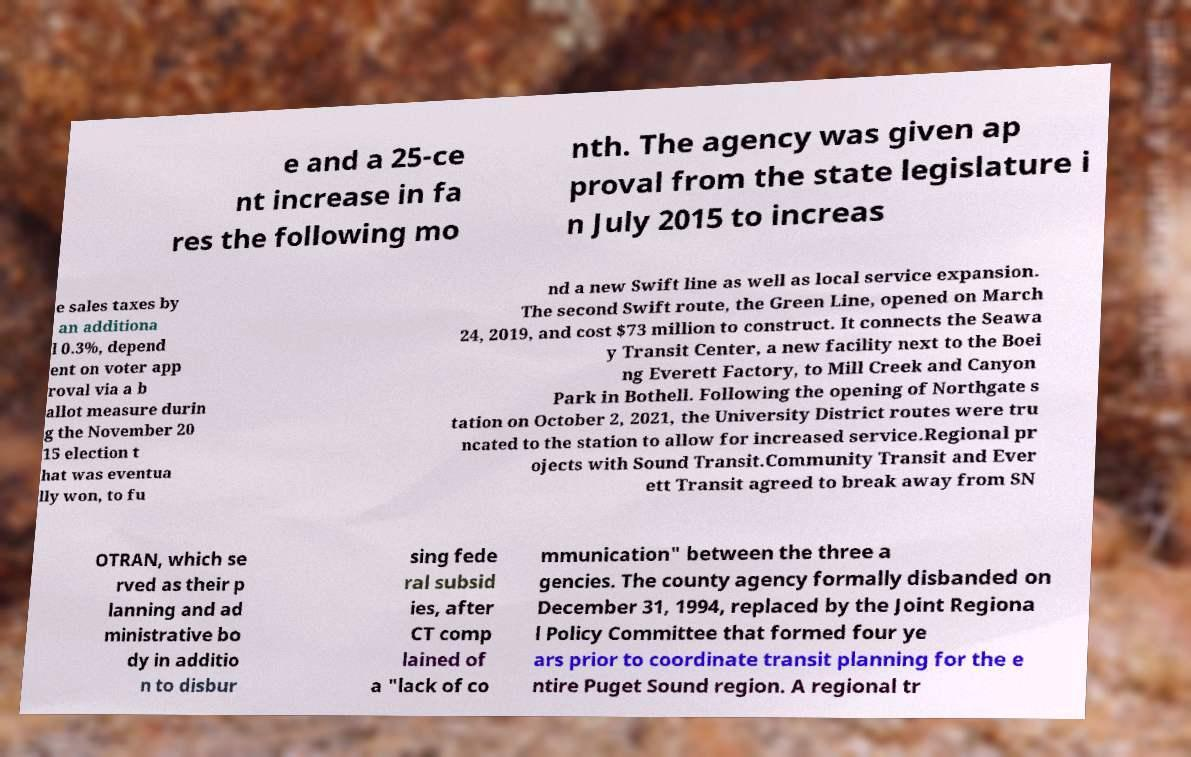Please read and relay the text visible in this image. What does it say? e and a 25-ce nt increase in fa res the following mo nth. The agency was given ap proval from the state legislature i n July 2015 to increas e sales taxes by an additiona l 0.3%, depend ent on voter app roval via a b allot measure durin g the November 20 15 election t hat was eventua lly won, to fu nd a new Swift line as well as local service expansion. The second Swift route, the Green Line, opened on March 24, 2019, and cost $73 million to construct. It connects the Seawa y Transit Center, a new facility next to the Boei ng Everett Factory, to Mill Creek and Canyon Park in Bothell. Following the opening of Northgate s tation on October 2, 2021, the University District routes were tru ncated to the station to allow for increased service.Regional pr ojects with Sound Transit.Community Transit and Ever ett Transit agreed to break away from SN OTRAN, which se rved as their p lanning and ad ministrative bo dy in additio n to disbur sing fede ral subsid ies, after CT comp lained of a "lack of co mmunication" between the three a gencies. The county agency formally disbanded on December 31, 1994, replaced by the Joint Regiona l Policy Committee that formed four ye ars prior to coordinate transit planning for the e ntire Puget Sound region. A regional tr 